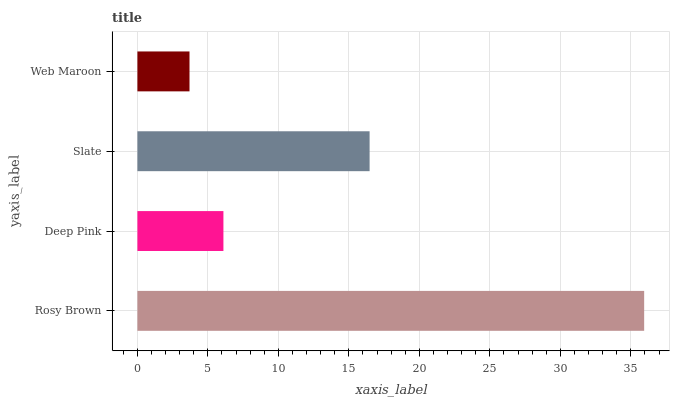Is Web Maroon the minimum?
Answer yes or no. Yes. Is Rosy Brown the maximum?
Answer yes or no. Yes. Is Deep Pink the minimum?
Answer yes or no. No. Is Deep Pink the maximum?
Answer yes or no. No. Is Rosy Brown greater than Deep Pink?
Answer yes or no. Yes. Is Deep Pink less than Rosy Brown?
Answer yes or no. Yes. Is Deep Pink greater than Rosy Brown?
Answer yes or no. No. Is Rosy Brown less than Deep Pink?
Answer yes or no. No. Is Slate the high median?
Answer yes or no. Yes. Is Deep Pink the low median?
Answer yes or no. Yes. Is Deep Pink the high median?
Answer yes or no. No. Is Rosy Brown the low median?
Answer yes or no. No. 